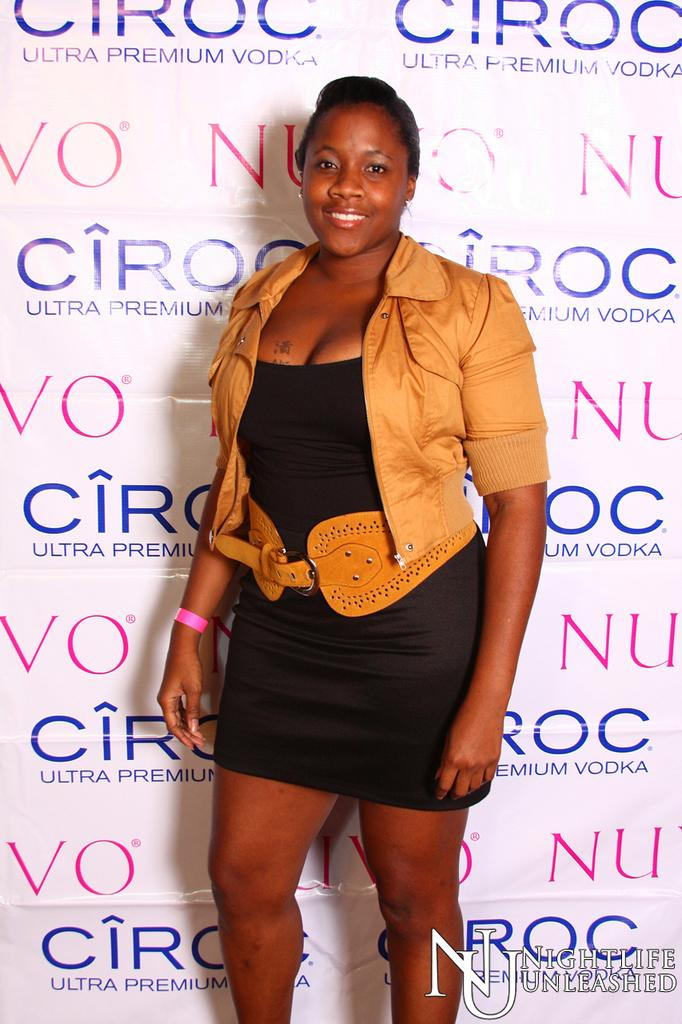Who is present in the image? There is a lady in the image. What is the lady doing in the image? The lady is standing with a smile on her face. What can be seen behind the lady? There is a wall behind the lady. What is written on the wall? The wall has a sponsor name on it. Can you hear the lady's voice in the image? The image is a still picture, so there is no sound or voice present. Is there a monkey in the image? No, there is no monkey present in the image; it features a lady standing with a smile on her face. 